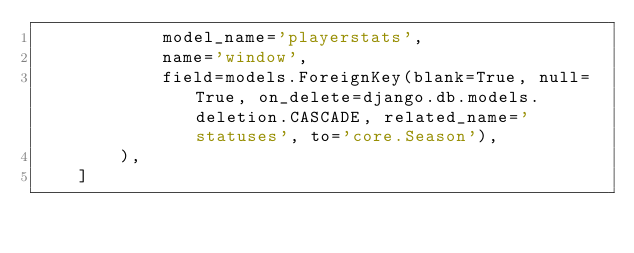Convert code to text. <code><loc_0><loc_0><loc_500><loc_500><_Python_>            model_name='playerstats',
            name='window',
            field=models.ForeignKey(blank=True, null=True, on_delete=django.db.models.deletion.CASCADE, related_name='statuses', to='core.Season'),
        ),
    ]
</code> 